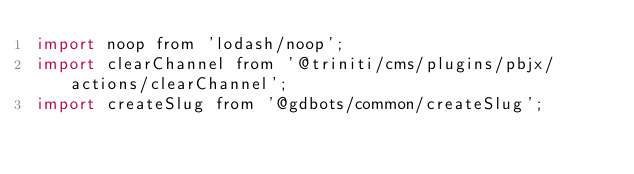<code> <loc_0><loc_0><loc_500><loc_500><_JavaScript_>import noop from 'lodash/noop';
import clearChannel from '@triniti/cms/plugins/pbjx/actions/clearChannel';
import createSlug from '@gdbots/common/createSlug';</code> 